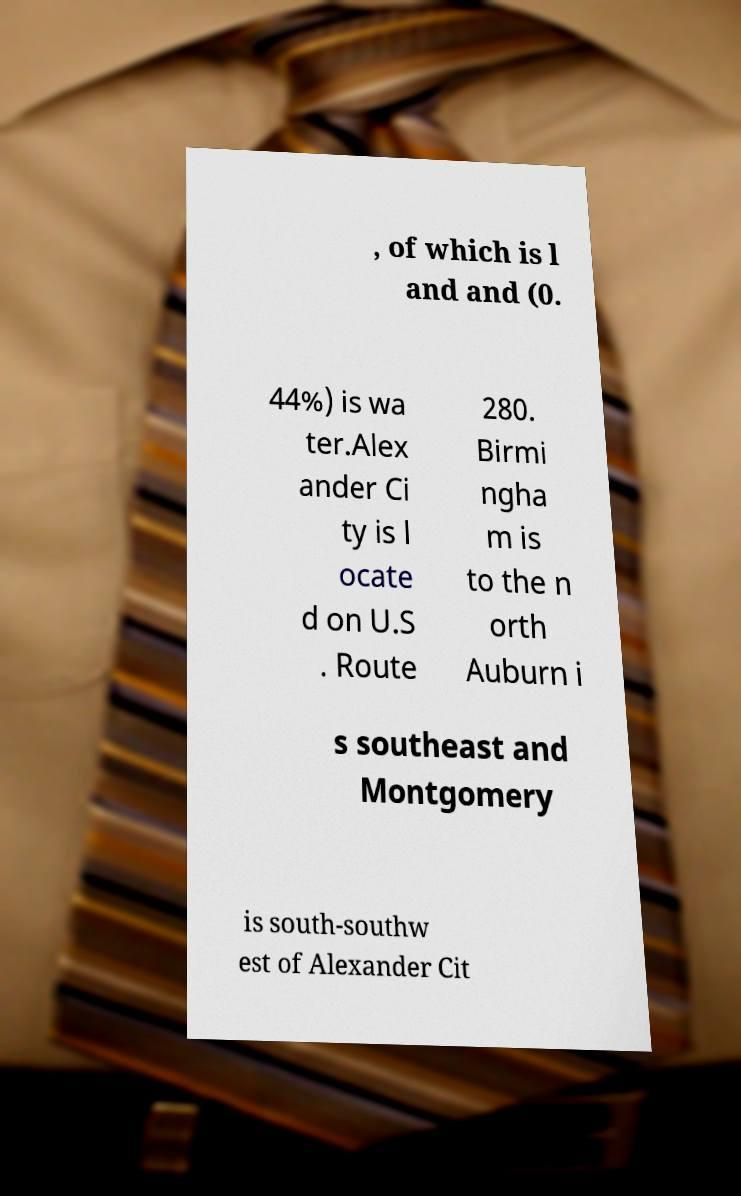For documentation purposes, I need the text within this image transcribed. Could you provide that? , of which is l and and (0. 44%) is wa ter.Alex ander Ci ty is l ocate d on U.S . Route 280. Birmi ngha m is to the n orth Auburn i s southeast and Montgomery is south-southw est of Alexander Cit 